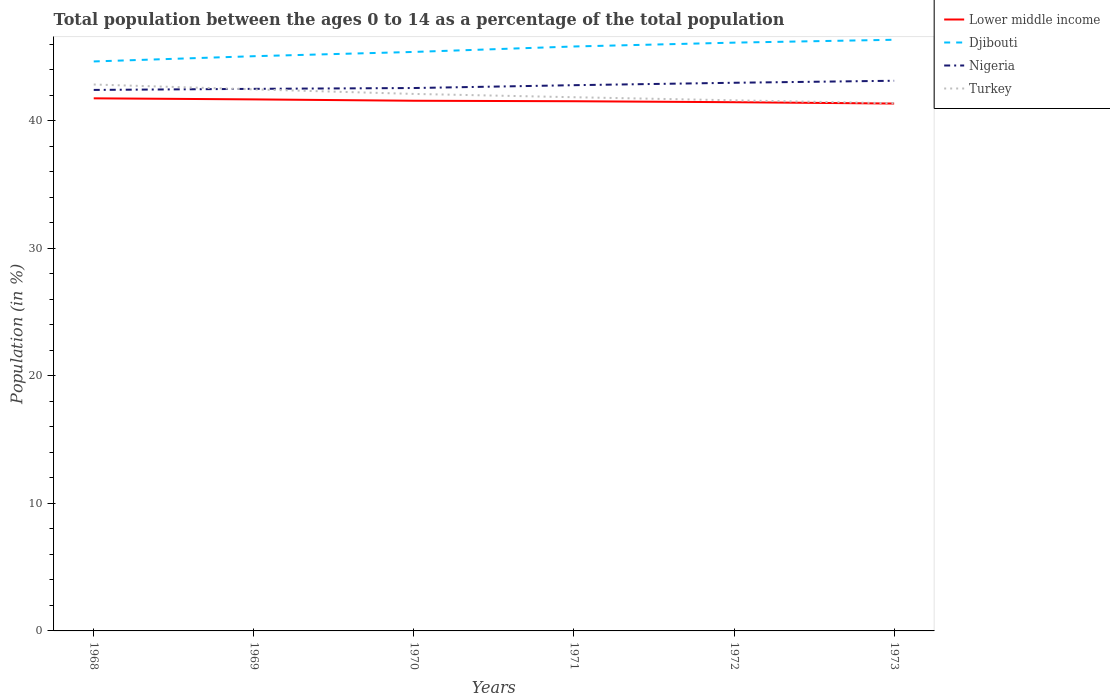Does the line corresponding to Lower middle income intersect with the line corresponding to Djibouti?
Your answer should be very brief. No. Is the number of lines equal to the number of legend labels?
Give a very brief answer. Yes. Across all years, what is the maximum percentage of the population ages 0 to 14 in Nigeria?
Your response must be concise. 42.42. What is the total percentage of the population ages 0 to 14 in Turkey in the graph?
Give a very brief answer. 0.73. What is the difference between the highest and the second highest percentage of the population ages 0 to 14 in Nigeria?
Keep it short and to the point. 0.72. What is the difference between the highest and the lowest percentage of the population ages 0 to 14 in Lower middle income?
Keep it short and to the point. 3. How many lines are there?
Give a very brief answer. 4. How many years are there in the graph?
Ensure brevity in your answer.  6. What is the difference between two consecutive major ticks on the Y-axis?
Your answer should be very brief. 10. Does the graph contain grids?
Your answer should be compact. No. How are the legend labels stacked?
Keep it short and to the point. Vertical. What is the title of the graph?
Provide a succinct answer. Total population between the ages 0 to 14 as a percentage of the total population. What is the label or title of the Y-axis?
Offer a terse response. Population (in %). What is the Population (in %) in Lower middle income in 1968?
Your answer should be compact. 41.76. What is the Population (in %) of Djibouti in 1968?
Ensure brevity in your answer.  44.66. What is the Population (in %) in Nigeria in 1968?
Provide a succinct answer. 42.42. What is the Population (in %) in Turkey in 1968?
Give a very brief answer. 42.85. What is the Population (in %) in Lower middle income in 1969?
Ensure brevity in your answer.  41.68. What is the Population (in %) of Djibouti in 1969?
Your answer should be compact. 45.07. What is the Population (in %) in Nigeria in 1969?
Ensure brevity in your answer.  42.51. What is the Population (in %) in Turkey in 1969?
Your response must be concise. 42.47. What is the Population (in %) in Lower middle income in 1970?
Offer a terse response. 41.57. What is the Population (in %) in Djibouti in 1970?
Make the answer very short. 45.4. What is the Population (in %) of Nigeria in 1970?
Your answer should be compact. 42.57. What is the Population (in %) of Turkey in 1970?
Your answer should be compact. 42.11. What is the Population (in %) of Lower middle income in 1971?
Offer a very short reply. 41.54. What is the Population (in %) of Djibouti in 1971?
Offer a very short reply. 45.83. What is the Population (in %) of Nigeria in 1971?
Your answer should be very brief. 42.8. What is the Population (in %) of Turkey in 1971?
Keep it short and to the point. 41.85. What is the Population (in %) in Lower middle income in 1972?
Provide a succinct answer. 41.46. What is the Population (in %) of Djibouti in 1972?
Your response must be concise. 46.13. What is the Population (in %) of Nigeria in 1972?
Your answer should be very brief. 42.99. What is the Population (in %) in Turkey in 1972?
Provide a short and direct response. 41.61. What is the Population (in %) of Lower middle income in 1973?
Give a very brief answer. 41.36. What is the Population (in %) of Djibouti in 1973?
Provide a short and direct response. 46.36. What is the Population (in %) of Nigeria in 1973?
Provide a succinct answer. 43.14. What is the Population (in %) of Turkey in 1973?
Your response must be concise. 41.38. Across all years, what is the maximum Population (in %) in Lower middle income?
Your answer should be very brief. 41.76. Across all years, what is the maximum Population (in %) of Djibouti?
Your answer should be compact. 46.36. Across all years, what is the maximum Population (in %) in Nigeria?
Offer a terse response. 43.14. Across all years, what is the maximum Population (in %) of Turkey?
Your answer should be very brief. 42.85. Across all years, what is the minimum Population (in %) of Lower middle income?
Your answer should be very brief. 41.36. Across all years, what is the minimum Population (in %) in Djibouti?
Offer a very short reply. 44.66. Across all years, what is the minimum Population (in %) of Nigeria?
Give a very brief answer. 42.42. Across all years, what is the minimum Population (in %) in Turkey?
Offer a terse response. 41.38. What is the total Population (in %) in Lower middle income in the graph?
Provide a short and direct response. 249.37. What is the total Population (in %) of Djibouti in the graph?
Your response must be concise. 273.45. What is the total Population (in %) of Nigeria in the graph?
Keep it short and to the point. 256.43. What is the total Population (in %) in Turkey in the graph?
Your response must be concise. 252.27. What is the difference between the Population (in %) of Lower middle income in 1968 and that in 1969?
Your answer should be compact. 0.08. What is the difference between the Population (in %) in Djibouti in 1968 and that in 1969?
Ensure brevity in your answer.  -0.41. What is the difference between the Population (in %) in Nigeria in 1968 and that in 1969?
Your answer should be compact. -0.08. What is the difference between the Population (in %) in Turkey in 1968 and that in 1969?
Ensure brevity in your answer.  0.38. What is the difference between the Population (in %) in Lower middle income in 1968 and that in 1970?
Give a very brief answer. 0.19. What is the difference between the Population (in %) in Djibouti in 1968 and that in 1970?
Provide a succinct answer. -0.75. What is the difference between the Population (in %) of Nigeria in 1968 and that in 1970?
Ensure brevity in your answer.  -0.15. What is the difference between the Population (in %) of Turkey in 1968 and that in 1970?
Make the answer very short. 0.74. What is the difference between the Population (in %) of Lower middle income in 1968 and that in 1971?
Offer a very short reply. 0.23. What is the difference between the Population (in %) of Djibouti in 1968 and that in 1971?
Give a very brief answer. -1.17. What is the difference between the Population (in %) of Nigeria in 1968 and that in 1971?
Keep it short and to the point. -0.37. What is the difference between the Population (in %) in Turkey in 1968 and that in 1971?
Keep it short and to the point. 1. What is the difference between the Population (in %) of Lower middle income in 1968 and that in 1972?
Your response must be concise. 0.3. What is the difference between the Population (in %) in Djibouti in 1968 and that in 1972?
Make the answer very short. -1.47. What is the difference between the Population (in %) in Nigeria in 1968 and that in 1972?
Offer a very short reply. -0.56. What is the difference between the Population (in %) in Turkey in 1968 and that in 1972?
Keep it short and to the point. 1.24. What is the difference between the Population (in %) of Lower middle income in 1968 and that in 1973?
Offer a very short reply. 0.41. What is the difference between the Population (in %) in Djibouti in 1968 and that in 1973?
Your answer should be compact. -1.7. What is the difference between the Population (in %) in Nigeria in 1968 and that in 1973?
Provide a succinct answer. -0.72. What is the difference between the Population (in %) of Turkey in 1968 and that in 1973?
Give a very brief answer. 1.47. What is the difference between the Population (in %) of Lower middle income in 1969 and that in 1970?
Ensure brevity in your answer.  0.11. What is the difference between the Population (in %) in Djibouti in 1969 and that in 1970?
Your answer should be compact. -0.34. What is the difference between the Population (in %) in Nigeria in 1969 and that in 1970?
Provide a short and direct response. -0.06. What is the difference between the Population (in %) of Turkey in 1969 and that in 1970?
Give a very brief answer. 0.36. What is the difference between the Population (in %) in Lower middle income in 1969 and that in 1971?
Your answer should be compact. 0.14. What is the difference between the Population (in %) in Djibouti in 1969 and that in 1971?
Keep it short and to the point. -0.76. What is the difference between the Population (in %) of Nigeria in 1969 and that in 1971?
Offer a terse response. -0.29. What is the difference between the Population (in %) of Turkey in 1969 and that in 1971?
Your answer should be compact. 0.62. What is the difference between the Population (in %) in Lower middle income in 1969 and that in 1972?
Ensure brevity in your answer.  0.22. What is the difference between the Population (in %) in Djibouti in 1969 and that in 1972?
Keep it short and to the point. -1.06. What is the difference between the Population (in %) in Nigeria in 1969 and that in 1972?
Offer a very short reply. -0.48. What is the difference between the Population (in %) in Turkey in 1969 and that in 1972?
Provide a succinct answer. 0.86. What is the difference between the Population (in %) in Lower middle income in 1969 and that in 1973?
Your answer should be very brief. 0.33. What is the difference between the Population (in %) in Djibouti in 1969 and that in 1973?
Your response must be concise. -1.29. What is the difference between the Population (in %) of Nigeria in 1969 and that in 1973?
Provide a short and direct response. -0.63. What is the difference between the Population (in %) in Turkey in 1969 and that in 1973?
Your answer should be compact. 1.09. What is the difference between the Population (in %) in Lower middle income in 1970 and that in 1971?
Your response must be concise. 0.04. What is the difference between the Population (in %) in Djibouti in 1970 and that in 1971?
Your response must be concise. -0.43. What is the difference between the Population (in %) in Nigeria in 1970 and that in 1971?
Offer a terse response. -0.22. What is the difference between the Population (in %) in Turkey in 1970 and that in 1971?
Offer a terse response. 0.26. What is the difference between the Population (in %) of Lower middle income in 1970 and that in 1972?
Ensure brevity in your answer.  0.11. What is the difference between the Population (in %) in Djibouti in 1970 and that in 1972?
Give a very brief answer. -0.73. What is the difference between the Population (in %) of Nigeria in 1970 and that in 1972?
Your answer should be very brief. -0.41. What is the difference between the Population (in %) in Turkey in 1970 and that in 1972?
Provide a short and direct response. 0.5. What is the difference between the Population (in %) in Lower middle income in 1970 and that in 1973?
Offer a very short reply. 0.22. What is the difference between the Population (in %) of Djibouti in 1970 and that in 1973?
Your answer should be compact. -0.95. What is the difference between the Population (in %) in Nigeria in 1970 and that in 1973?
Make the answer very short. -0.57. What is the difference between the Population (in %) of Turkey in 1970 and that in 1973?
Your answer should be compact. 0.73. What is the difference between the Population (in %) of Lower middle income in 1971 and that in 1972?
Your response must be concise. 0.08. What is the difference between the Population (in %) in Djibouti in 1971 and that in 1972?
Ensure brevity in your answer.  -0.3. What is the difference between the Population (in %) in Nigeria in 1971 and that in 1972?
Make the answer very short. -0.19. What is the difference between the Population (in %) of Turkey in 1971 and that in 1972?
Offer a terse response. 0.24. What is the difference between the Population (in %) of Lower middle income in 1971 and that in 1973?
Keep it short and to the point. 0.18. What is the difference between the Population (in %) in Djibouti in 1971 and that in 1973?
Your answer should be very brief. -0.53. What is the difference between the Population (in %) in Nigeria in 1971 and that in 1973?
Ensure brevity in your answer.  -0.35. What is the difference between the Population (in %) of Turkey in 1971 and that in 1973?
Your answer should be very brief. 0.47. What is the difference between the Population (in %) in Lower middle income in 1972 and that in 1973?
Offer a terse response. 0.11. What is the difference between the Population (in %) of Djibouti in 1972 and that in 1973?
Provide a succinct answer. -0.23. What is the difference between the Population (in %) in Nigeria in 1972 and that in 1973?
Your response must be concise. -0.16. What is the difference between the Population (in %) of Turkey in 1972 and that in 1973?
Make the answer very short. 0.23. What is the difference between the Population (in %) of Lower middle income in 1968 and the Population (in %) of Djibouti in 1969?
Your answer should be very brief. -3.3. What is the difference between the Population (in %) in Lower middle income in 1968 and the Population (in %) in Nigeria in 1969?
Offer a terse response. -0.74. What is the difference between the Population (in %) in Lower middle income in 1968 and the Population (in %) in Turkey in 1969?
Your answer should be compact. -0.7. What is the difference between the Population (in %) of Djibouti in 1968 and the Population (in %) of Nigeria in 1969?
Ensure brevity in your answer.  2.15. What is the difference between the Population (in %) in Djibouti in 1968 and the Population (in %) in Turkey in 1969?
Provide a succinct answer. 2.19. What is the difference between the Population (in %) in Nigeria in 1968 and the Population (in %) in Turkey in 1969?
Provide a succinct answer. -0.04. What is the difference between the Population (in %) in Lower middle income in 1968 and the Population (in %) in Djibouti in 1970?
Your answer should be very brief. -3.64. What is the difference between the Population (in %) in Lower middle income in 1968 and the Population (in %) in Nigeria in 1970?
Offer a terse response. -0.81. What is the difference between the Population (in %) of Lower middle income in 1968 and the Population (in %) of Turkey in 1970?
Provide a short and direct response. -0.35. What is the difference between the Population (in %) in Djibouti in 1968 and the Population (in %) in Nigeria in 1970?
Your answer should be compact. 2.08. What is the difference between the Population (in %) in Djibouti in 1968 and the Population (in %) in Turkey in 1970?
Offer a very short reply. 2.55. What is the difference between the Population (in %) in Nigeria in 1968 and the Population (in %) in Turkey in 1970?
Offer a terse response. 0.31. What is the difference between the Population (in %) of Lower middle income in 1968 and the Population (in %) of Djibouti in 1971?
Ensure brevity in your answer.  -4.07. What is the difference between the Population (in %) in Lower middle income in 1968 and the Population (in %) in Nigeria in 1971?
Provide a succinct answer. -1.03. What is the difference between the Population (in %) of Lower middle income in 1968 and the Population (in %) of Turkey in 1971?
Offer a terse response. -0.09. What is the difference between the Population (in %) in Djibouti in 1968 and the Population (in %) in Nigeria in 1971?
Your answer should be compact. 1.86. What is the difference between the Population (in %) in Djibouti in 1968 and the Population (in %) in Turkey in 1971?
Your response must be concise. 2.81. What is the difference between the Population (in %) of Nigeria in 1968 and the Population (in %) of Turkey in 1971?
Give a very brief answer. 0.57. What is the difference between the Population (in %) of Lower middle income in 1968 and the Population (in %) of Djibouti in 1972?
Your response must be concise. -4.37. What is the difference between the Population (in %) in Lower middle income in 1968 and the Population (in %) in Nigeria in 1972?
Ensure brevity in your answer.  -1.22. What is the difference between the Population (in %) in Lower middle income in 1968 and the Population (in %) in Turkey in 1972?
Give a very brief answer. 0.15. What is the difference between the Population (in %) in Djibouti in 1968 and the Population (in %) in Nigeria in 1972?
Offer a very short reply. 1.67. What is the difference between the Population (in %) of Djibouti in 1968 and the Population (in %) of Turkey in 1972?
Your response must be concise. 3.05. What is the difference between the Population (in %) in Nigeria in 1968 and the Population (in %) in Turkey in 1972?
Give a very brief answer. 0.81. What is the difference between the Population (in %) in Lower middle income in 1968 and the Population (in %) in Djibouti in 1973?
Your answer should be very brief. -4.59. What is the difference between the Population (in %) of Lower middle income in 1968 and the Population (in %) of Nigeria in 1973?
Make the answer very short. -1.38. What is the difference between the Population (in %) in Lower middle income in 1968 and the Population (in %) in Turkey in 1973?
Offer a very short reply. 0.39. What is the difference between the Population (in %) in Djibouti in 1968 and the Population (in %) in Nigeria in 1973?
Your answer should be very brief. 1.51. What is the difference between the Population (in %) of Djibouti in 1968 and the Population (in %) of Turkey in 1973?
Make the answer very short. 3.28. What is the difference between the Population (in %) of Nigeria in 1968 and the Population (in %) of Turkey in 1973?
Offer a terse response. 1.04. What is the difference between the Population (in %) in Lower middle income in 1969 and the Population (in %) in Djibouti in 1970?
Offer a terse response. -3.72. What is the difference between the Population (in %) in Lower middle income in 1969 and the Population (in %) in Nigeria in 1970?
Make the answer very short. -0.89. What is the difference between the Population (in %) of Lower middle income in 1969 and the Population (in %) of Turkey in 1970?
Make the answer very short. -0.43. What is the difference between the Population (in %) in Djibouti in 1969 and the Population (in %) in Nigeria in 1970?
Provide a succinct answer. 2.5. What is the difference between the Population (in %) of Djibouti in 1969 and the Population (in %) of Turkey in 1970?
Make the answer very short. 2.96. What is the difference between the Population (in %) of Nigeria in 1969 and the Population (in %) of Turkey in 1970?
Your response must be concise. 0.4. What is the difference between the Population (in %) of Lower middle income in 1969 and the Population (in %) of Djibouti in 1971?
Your answer should be very brief. -4.15. What is the difference between the Population (in %) in Lower middle income in 1969 and the Population (in %) in Nigeria in 1971?
Give a very brief answer. -1.11. What is the difference between the Population (in %) in Lower middle income in 1969 and the Population (in %) in Turkey in 1971?
Your answer should be very brief. -0.17. What is the difference between the Population (in %) of Djibouti in 1969 and the Population (in %) of Nigeria in 1971?
Your answer should be compact. 2.27. What is the difference between the Population (in %) of Djibouti in 1969 and the Population (in %) of Turkey in 1971?
Make the answer very short. 3.22. What is the difference between the Population (in %) in Nigeria in 1969 and the Population (in %) in Turkey in 1971?
Make the answer very short. 0.66. What is the difference between the Population (in %) of Lower middle income in 1969 and the Population (in %) of Djibouti in 1972?
Your answer should be compact. -4.45. What is the difference between the Population (in %) of Lower middle income in 1969 and the Population (in %) of Nigeria in 1972?
Your answer should be compact. -1.3. What is the difference between the Population (in %) in Lower middle income in 1969 and the Population (in %) in Turkey in 1972?
Offer a very short reply. 0.07. What is the difference between the Population (in %) in Djibouti in 1969 and the Population (in %) in Nigeria in 1972?
Your answer should be compact. 2.08. What is the difference between the Population (in %) in Djibouti in 1969 and the Population (in %) in Turkey in 1972?
Your answer should be very brief. 3.46. What is the difference between the Population (in %) in Nigeria in 1969 and the Population (in %) in Turkey in 1972?
Make the answer very short. 0.9. What is the difference between the Population (in %) in Lower middle income in 1969 and the Population (in %) in Djibouti in 1973?
Offer a very short reply. -4.68. What is the difference between the Population (in %) in Lower middle income in 1969 and the Population (in %) in Nigeria in 1973?
Give a very brief answer. -1.46. What is the difference between the Population (in %) of Lower middle income in 1969 and the Population (in %) of Turkey in 1973?
Provide a succinct answer. 0.3. What is the difference between the Population (in %) in Djibouti in 1969 and the Population (in %) in Nigeria in 1973?
Keep it short and to the point. 1.93. What is the difference between the Population (in %) in Djibouti in 1969 and the Population (in %) in Turkey in 1973?
Your response must be concise. 3.69. What is the difference between the Population (in %) in Nigeria in 1969 and the Population (in %) in Turkey in 1973?
Your response must be concise. 1.13. What is the difference between the Population (in %) in Lower middle income in 1970 and the Population (in %) in Djibouti in 1971?
Your answer should be very brief. -4.26. What is the difference between the Population (in %) of Lower middle income in 1970 and the Population (in %) of Nigeria in 1971?
Make the answer very short. -1.22. What is the difference between the Population (in %) in Lower middle income in 1970 and the Population (in %) in Turkey in 1971?
Your answer should be compact. -0.28. What is the difference between the Population (in %) in Djibouti in 1970 and the Population (in %) in Nigeria in 1971?
Give a very brief answer. 2.61. What is the difference between the Population (in %) in Djibouti in 1970 and the Population (in %) in Turkey in 1971?
Offer a very short reply. 3.55. What is the difference between the Population (in %) in Nigeria in 1970 and the Population (in %) in Turkey in 1971?
Your answer should be compact. 0.72. What is the difference between the Population (in %) in Lower middle income in 1970 and the Population (in %) in Djibouti in 1972?
Offer a terse response. -4.56. What is the difference between the Population (in %) in Lower middle income in 1970 and the Population (in %) in Nigeria in 1972?
Provide a short and direct response. -1.41. What is the difference between the Population (in %) of Lower middle income in 1970 and the Population (in %) of Turkey in 1972?
Your answer should be very brief. -0.04. What is the difference between the Population (in %) of Djibouti in 1970 and the Population (in %) of Nigeria in 1972?
Your answer should be very brief. 2.42. What is the difference between the Population (in %) of Djibouti in 1970 and the Population (in %) of Turkey in 1972?
Provide a succinct answer. 3.79. What is the difference between the Population (in %) in Nigeria in 1970 and the Population (in %) in Turkey in 1972?
Provide a succinct answer. 0.96. What is the difference between the Population (in %) of Lower middle income in 1970 and the Population (in %) of Djibouti in 1973?
Make the answer very short. -4.78. What is the difference between the Population (in %) in Lower middle income in 1970 and the Population (in %) in Nigeria in 1973?
Ensure brevity in your answer.  -1.57. What is the difference between the Population (in %) of Lower middle income in 1970 and the Population (in %) of Turkey in 1973?
Offer a very short reply. 0.19. What is the difference between the Population (in %) in Djibouti in 1970 and the Population (in %) in Nigeria in 1973?
Offer a terse response. 2.26. What is the difference between the Population (in %) in Djibouti in 1970 and the Population (in %) in Turkey in 1973?
Ensure brevity in your answer.  4.02. What is the difference between the Population (in %) of Nigeria in 1970 and the Population (in %) of Turkey in 1973?
Your answer should be very brief. 1.19. What is the difference between the Population (in %) in Lower middle income in 1971 and the Population (in %) in Djibouti in 1972?
Your answer should be very brief. -4.6. What is the difference between the Population (in %) in Lower middle income in 1971 and the Population (in %) in Nigeria in 1972?
Keep it short and to the point. -1.45. What is the difference between the Population (in %) in Lower middle income in 1971 and the Population (in %) in Turkey in 1972?
Keep it short and to the point. -0.07. What is the difference between the Population (in %) of Djibouti in 1971 and the Population (in %) of Nigeria in 1972?
Offer a terse response. 2.85. What is the difference between the Population (in %) of Djibouti in 1971 and the Population (in %) of Turkey in 1972?
Provide a short and direct response. 4.22. What is the difference between the Population (in %) in Nigeria in 1971 and the Population (in %) in Turkey in 1972?
Your answer should be very brief. 1.19. What is the difference between the Population (in %) of Lower middle income in 1971 and the Population (in %) of Djibouti in 1973?
Keep it short and to the point. -4.82. What is the difference between the Population (in %) in Lower middle income in 1971 and the Population (in %) in Nigeria in 1973?
Your answer should be compact. -1.61. What is the difference between the Population (in %) in Lower middle income in 1971 and the Population (in %) in Turkey in 1973?
Offer a very short reply. 0.16. What is the difference between the Population (in %) in Djibouti in 1971 and the Population (in %) in Nigeria in 1973?
Make the answer very short. 2.69. What is the difference between the Population (in %) in Djibouti in 1971 and the Population (in %) in Turkey in 1973?
Make the answer very short. 4.45. What is the difference between the Population (in %) in Nigeria in 1971 and the Population (in %) in Turkey in 1973?
Keep it short and to the point. 1.42. What is the difference between the Population (in %) of Lower middle income in 1972 and the Population (in %) of Djibouti in 1973?
Provide a succinct answer. -4.9. What is the difference between the Population (in %) in Lower middle income in 1972 and the Population (in %) in Nigeria in 1973?
Provide a short and direct response. -1.68. What is the difference between the Population (in %) in Lower middle income in 1972 and the Population (in %) in Turkey in 1973?
Offer a terse response. 0.08. What is the difference between the Population (in %) of Djibouti in 1972 and the Population (in %) of Nigeria in 1973?
Your response must be concise. 2.99. What is the difference between the Population (in %) of Djibouti in 1972 and the Population (in %) of Turkey in 1973?
Your response must be concise. 4.75. What is the difference between the Population (in %) of Nigeria in 1972 and the Population (in %) of Turkey in 1973?
Provide a succinct answer. 1.61. What is the average Population (in %) in Lower middle income per year?
Your answer should be compact. 41.56. What is the average Population (in %) of Djibouti per year?
Make the answer very short. 45.57. What is the average Population (in %) in Nigeria per year?
Offer a terse response. 42.74. What is the average Population (in %) of Turkey per year?
Offer a terse response. 42.04. In the year 1968, what is the difference between the Population (in %) in Lower middle income and Population (in %) in Djibouti?
Your answer should be compact. -2.89. In the year 1968, what is the difference between the Population (in %) of Lower middle income and Population (in %) of Nigeria?
Ensure brevity in your answer.  -0.66. In the year 1968, what is the difference between the Population (in %) of Lower middle income and Population (in %) of Turkey?
Your response must be concise. -1.08. In the year 1968, what is the difference between the Population (in %) of Djibouti and Population (in %) of Nigeria?
Ensure brevity in your answer.  2.23. In the year 1968, what is the difference between the Population (in %) of Djibouti and Population (in %) of Turkey?
Your answer should be compact. 1.81. In the year 1968, what is the difference between the Population (in %) in Nigeria and Population (in %) in Turkey?
Give a very brief answer. -0.43. In the year 1969, what is the difference between the Population (in %) in Lower middle income and Population (in %) in Djibouti?
Offer a terse response. -3.39. In the year 1969, what is the difference between the Population (in %) in Lower middle income and Population (in %) in Nigeria?
Your answer should be compact. -0.83. In the year 1969, what is the difference between the Population (in %) of Lower middle income and Population (in %) of Turkey?
Give a very brief answer. -0.78. In the year 1969, what is the difference between the Population (in %) of Djibouti and Population (in %) of Nigeria?
Provide a succinct answer. 2.56. In the year 1969, what is the difference between the Population (in %) in Djibouti and Population (in %) in Turkey?
Offer a terse response. 2.6. In the year 1969, what is the difference between the Population (in %) in Nigeria and Population (in %) in Turkey?
Ensure brevity in your answer.  0.04. In the year 1970, what is the difference between the Population (in %) of Lower middle income and Population (in %) of Djibouti?
Provide a succinct answer. -3.83. In the year 1970, what is the difference between the Population (in %) in Lower middle income and Population (in %) in Nigeria?
Give a very brief answer. -1. In the year 1970, what is the difference between the Population (in %) in Lower middle income and Population (in %) in Turkey?
Provide a succinct answer. -0.54. In the year 1970, what is the difference between the Population (in %) in Djibouti and Population (in %) in Nigeria?
Provide a short and direct response. 2.83. In the year 1970, what is the difference between the Population (in %) of Djibouti and Population (in %) of Turkey?
Offer a very short reply. 3.29. In the year 1970, what is the difference between the Population (in %) in Nigeria and Population (in %) in Turkey?
Give a very brief answer. 0.46. In the year 1971, what is the difference between the Population (in %) of Lower middle income and Population (in %) of Djibouti?
Provide a succinct answer. -4.29. In the year 1971, what is the difference between the Population (in %) in Lower middle income and Population (in %) in Nigeria?
Make the answer very short. -1.26. In the year 1971, what is the difference between the Population (in %) in Lower middle income and Population (in %) in Turkey?
Your answer should be compact. -0.31. In the year 1971, what is the difference between the Population (in %) of Djibouti and Population (in %) of Nigeria?
Offer a very short reply. 3.04. In the year 1971, what is the difference between the Population (in %) in Djibouti and Population (in %) in Turkey?
Provide a short and direct response. 3.98. In the year 1971, what is the difference between the Population (in %) of Nigeria and Population (in %) of Turkey?
Give a very brief answer. 0.94. In the year 1972, what is the difference between the Population (in %) of Lower middle income and Population (in %) of Djibouti?
Provide a succinct answer. -4.67. In the year 1972, what is the difference between the Population (in %) in Lower middle income and Population (in %) in Nigeria?
Ensure brevity in your answer.  -1.52. In the year 1972, what is the difference between the Population (in %) in Lower middle income and Population (in %) in Turkey?
Your answer should be very brief. -0.15. In the year 1972, what is the difference between the Population (in %) of Djibouti and Population (in %) of Nigeria?
Ensure brevity in your answer.  3.15. In the year 1972, what is the difference between the Population (in %) in Djibouti and Population (in %) in Turkey?
Your answer should be very brief. 4.52. In the year 1972, what is the difference between the Population (in %) of Nigeria and Population (in %) of Turkey?
Offer a terse response. 1.38. In the year 1973, what is the difference between the Population (in %) of Lower middle income and Population (in %) of Djibouti?
Your answer should be compact. -5. In the year 1973, what is the difference between the Population (in %) in Lower middle income and Population (in %) in Nigeria?
Make the answer very short. -1.79. In the year 1973, what is the difference between the Population (in %) in Lower middle income and Population (in %) in Turkey?
Keep it short and to the point. -0.02. In the year 1973, what is the difference between the Population (in %) in Djibouti and Population (in %) in Nigeria?
Keep it short and to the point. 3.21. In the year 1973, what is the difference between the Population (in %) of Djibouti and Population (in %) of Turkey?
Your answer should be compact. 4.98. In the year 1973, what is the difference between the Population (in %) of Nigeria and Population (in %) of Turkey?
Your response must be concise. 1.76. What is the ratio of the Population (in %) of Lower middle income in 1968 to that in 1969?
Make the answer very short. 1. What is the ratio of the Population (in %) of Djibouti in 1968 to that in 1969?
Keep it short and to the point. 0.99. What is the ratio of the Population (in %) in Nigeria in 1968 to that in 1969?
Offer a very short reply. 1. What is the ratio of the Population (in %) in Turkey in 1968 to that in 1969?
Your answer should be very brief. 1.01. What is the ratio of the Population (in %) of Djibouti in 1968 to that in 1970?
Your response must be concise. 0.98. What is the ratio of the Population (in %) of Nigeria in 1968 to that in 1970?
Offer a very short reply. 1. What is the ratio of the Population (in %) of Turkey in 1968 to that in 1970?
Make the answer very short. 1.02. What is the ratio of the Population (in %) of Djibouti in 1968 to that in 1971?
Provide a succinct answer. 0.97. What is the ratio of the Population (in %) in Nigeria in 1968 to that in 1971?
Keep it short and to the point. 0.99. What is the ratio of the Population (in %) in Turkey in 1968 to that in 1971?
Provide a succinct answer. 1.02. What is the ratio of the Population (in %) in Lower middle income in 1968 to that in 1972?
Keep it short and to the point. 1.01. What is the ratio of the Population (in %) of Nigeria in 1968 to that in 1972?
Keep it short and to the point. 0.99. What is the ratio of the Population (in %) in Turkey in 1968 to that in 1972?
Provide a short and direct response. 1.03. What is the ratio of the Population (in %) in Lower middle income in 1968 to that in 1973?
Offer a terse response. 1.01. What is the ratio of the Population (in %) of Djibouti in 1968 to that in 1973?
Give a very brief answer. 0.96. What is the ratio of the Population (in %) of Nigeria in 1968 to that in 1973?
Your answer should be very brief. 0.98. What is the ratio of the Population (in %) of Turkey in 1968 to that in 1973?
Your answer should be very brief. 1.04. What is the ratio of the Population (in %) of Lower middle income in 1969 to that in 1970?
Give a very brief answer. 1. What is the ratio of the Population (in %) in Djibouti in 1969 to that in 1970?
Your answer should be compact. 0.99. What is the ratio of the Population (in %) of Turkey in 1969 to that in 1970?
Offer a terse response. 1.01. What is the ratio of the Population (in %) in Djibouti in 1969 to that in 1971?
Give a very brief answer. 0.98. What is the ratio of the Population (in %) in Nigeria in 1969 to that in 1971?
Keep it short and to the point. 0.99. What is the ratio of the Population (in %) in Turkey in 1969 to that in 1971?
Offer a terse response. 1.01. What is the ratio of the Population (in %) of Djibouti in 1969 to that in 1972?
Keep it short and to the point. 0.98. What is the ratio of the Population (in %) of Nigeria in 1969 to that in 1972?
Make the answer very short. 0.99. What is the ratio of the Population (in %) in Turkey in 1969 to that in 1972?
Your response must be concise. 1.02. What is the ratio of the Population (in %) of Lower middle income in 1969 to that in 1973?
Give a very brief answer. 1.01. What is the ratio of the Population (in %) of Djibouti in 1969 to that in 1973?
Make the answer very short. 0.97. What is the ratio of the Population (in %) of Turkey in 1969 to that in 1973?
Your answer should be very brief. 1.03. What is the ratio of the Population (in %) in Lower middle income in 1970 to that in 1971?
Your answer should be compact. 1. What is the ratio of the Population (in %) in Djibouti in 1970 to that in 1971?
Offer a terse response. 0.99. What is the ratio of the Population (in %) in Nigeria in 1970 to that in 1971?
Your answer should be compact. 0.99. What is the ratio of the Population (in %) in Turkey in 1970 to that in 1971?
Make the answer very short. 1.01. What is the ratio of the Population (in %) in Lower middle income in 1970 to that in 1972?
Your response must be concise. 1. What is the ratio of the Population (in %) of Djibouti in 1970 to that in 1972?
Provide a short and direct response. 0.98. What is the ratio of the Population (in %) in Nigeria in 1970 to that in 1972?
Make the answer very short. 0.99. What is the ratio of the Population (in %) of Djibouti in 1970 to that in 1973?
Provide a succinct answer. 0.98. What is the ratio of the Population (in %) in Turkey in 1970 to that in 1973?
Offer a terse response. 1.02. What is the ratio of the Population (in %) of Lower middle income in 1971 to that in 1972?
Keep it short and to the point. 1. What is the ratio of the Population (in %) in Nigeria in 1971 to that in 1972?
Your answer should be compact. 1. What is the ratio of the Population (in %) in Turkey in 1971 to that in 1972?
Offer a very short reply. 1.01. What is the ratio of the Population (in %) in Djibouti in 1971 to that in 1973?
Offer a very short reply. 0.99. What is the ratio of the Population (in %) in Turkey in 1971 to that in 1973?
Ensure brevity in your answer.  1.01. What is the ratio of the Population (in %) in Lower middle income in 1972 to that in 1973?
Your response must be concise. 1. What is the ratio of the Population (in %) of Djibouti in 1972 to that in 1973?
Keep it short and to the point. 1. What is the ratio of the Population (in %) of Turkey in 1972 to that in 1973?
Provide a short and direct response. 1.01. What is the difference between the highest and the second highest Population (in %) in Lower middle income?
Offer a very short reply. 0.08. What is the difference between the highest and the second highest Population (in %) in Djibouti?
Give a very brief answer. 0.23. What is the difference between the highest and the second highest Population (in %) in Nigeria?
Make the answer very short. 0.16. What is the difference between the highest and the second highest Population (in %) in Turkey?
Offer a terse response. 0.38. What is the difference between the highest and the lowest Population (in %) in Lower middle income?
Your answer should be very brief. 0.41. What is the difference between the highest and the lowest Population (in %) in Djibouti?
Give a very brief answer. 1.7. What is the difference between the highest and the lowest Population (in %) of Nigeria?
Your response must be concise. 0.72. What is the difference between the highest and the lowest Population (in %) in Turkey?
Make the answer very short. 1.47. 